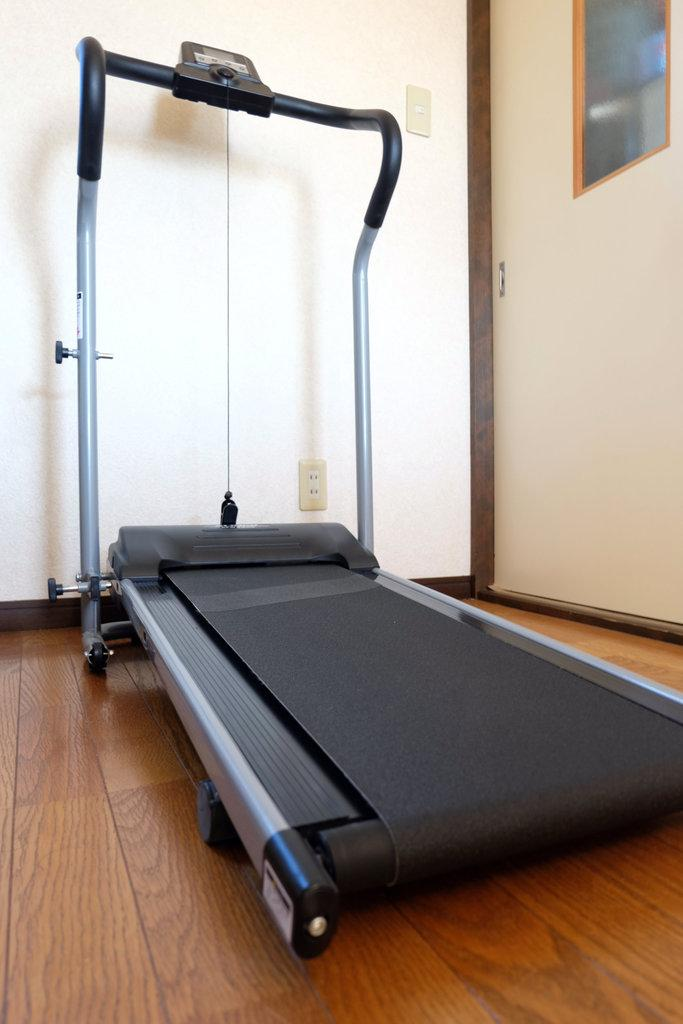What exercise equipment is present in the image? There is a treadmill in the image. What type of flooring is beneath the treadmill? The treadmill is on a wooden floor. What can be seen in the background of the image? There is a wall and a door in the background of the image. What road is visible in the image? There is no road visible in the image; it features a treadmill on a wooden floor with a wall and a door in the background. 